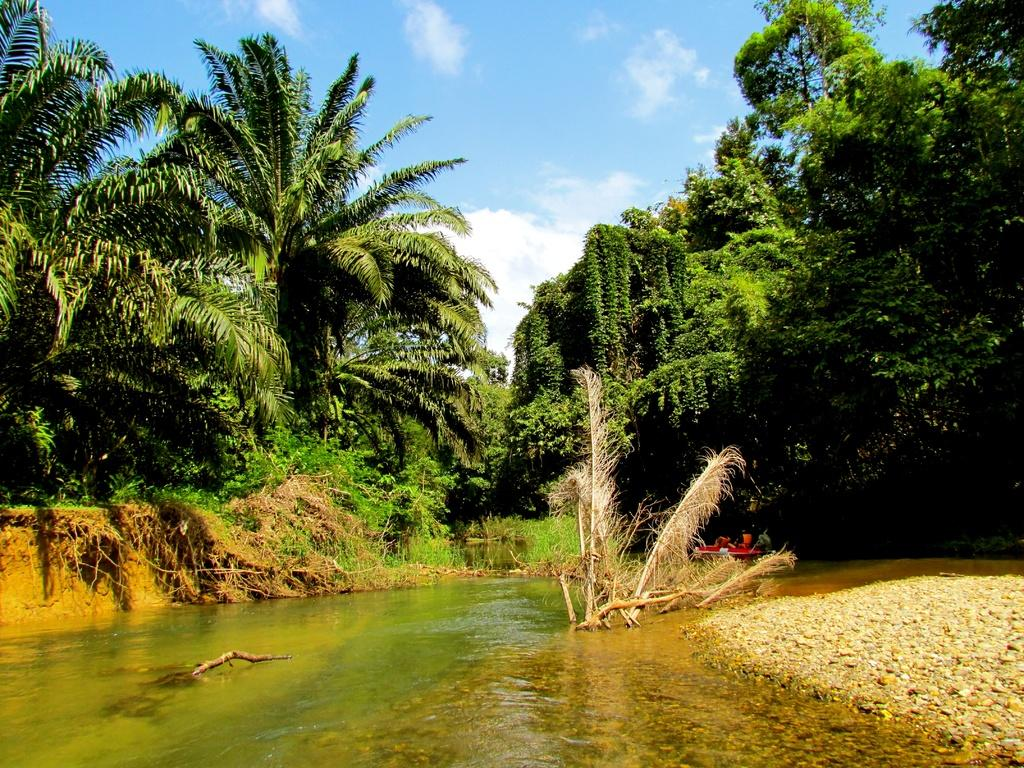What is present in the image that is not solid? There is water visible in the image. What objects can be seen in the image that are not living organisms? There are stones in the image. What can be seen in the background of the image? There are trees visible in the background of the image. What is visible in the sky in the image? The sky is visible in the image, and it appears to be cloudy. What decision can be seen being made by the heat in the image? There is no heat present in the image, and therefore no decision can be made by it. 